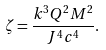<formula> <loc_0><loc_0><loc_500><loc_500>\zeta = \frac { k ^ { 3 } Q ^ { 2 } M ^ { 2 } } { J ^ { 4 } c ^ { 4 } } .</formula> 